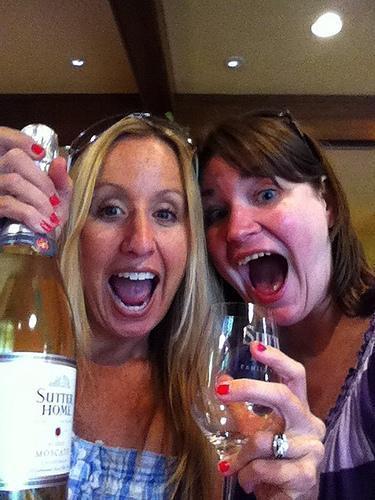How many women are drinking?
Give a very brief answer. 2. 